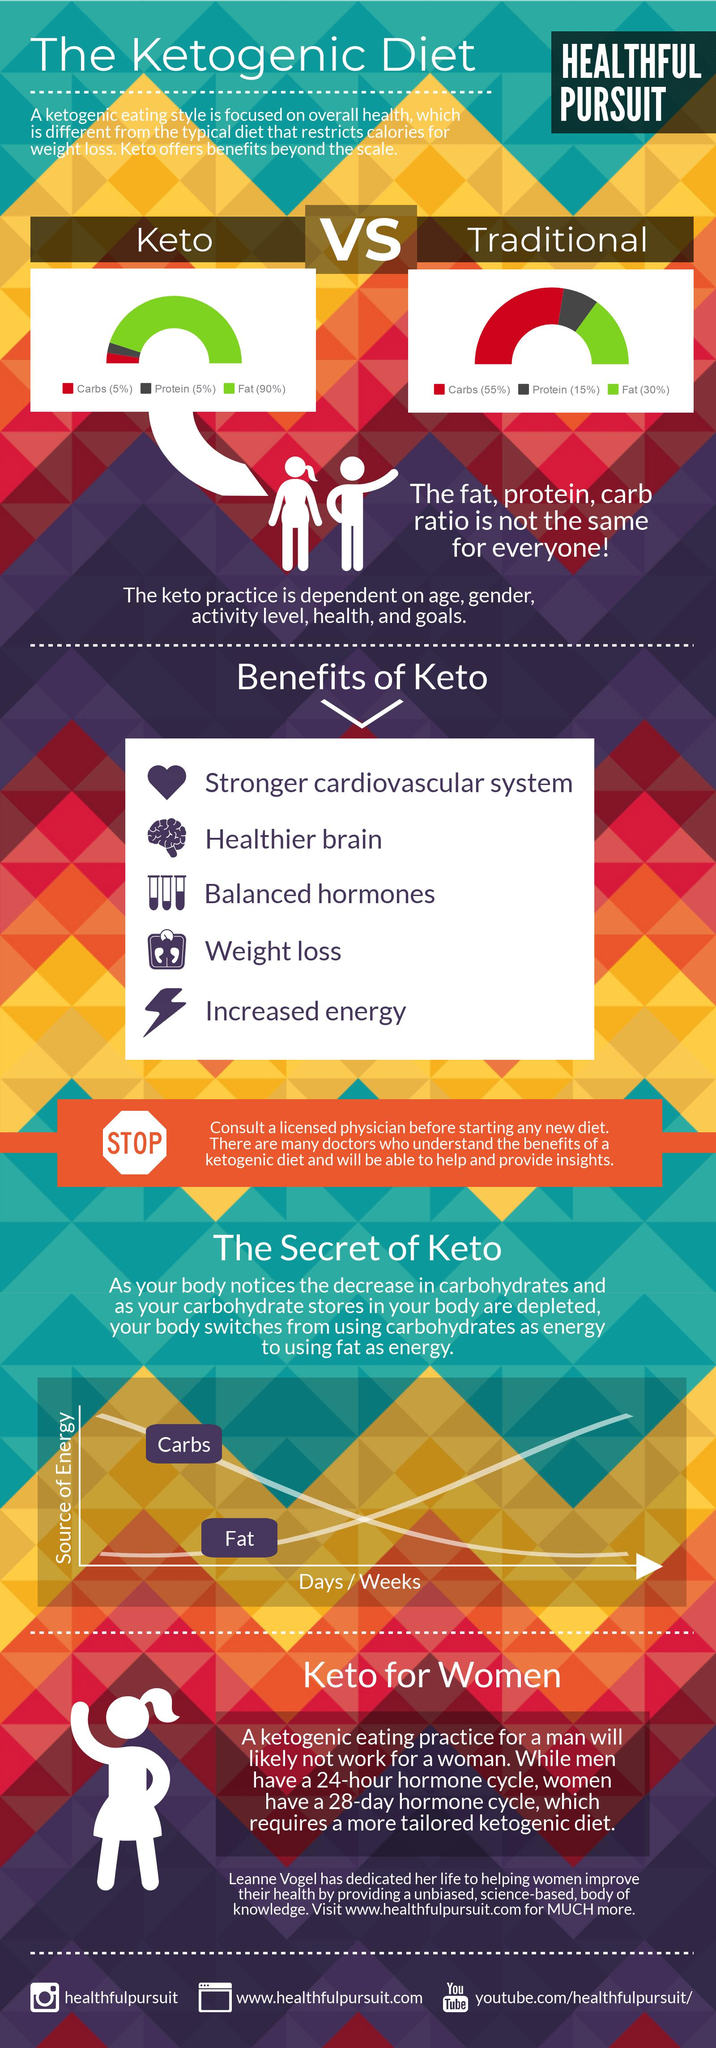Draw attention to some important aspects in this diagram. According to the Keto diet, it is recommended to incorporate 90% of fat in your daily meals. 